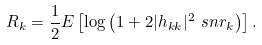Convert formula to latex. <formula><loc_0><loc_0><loc_500><loc_500>R _ { k } = \frac { 1 } { 2 } E \left [ \log { \left ( 1 + 2 | h _ { k k } | ^ { 2 } \ s n r _ { k } \right ) } \right ] .</formula> 